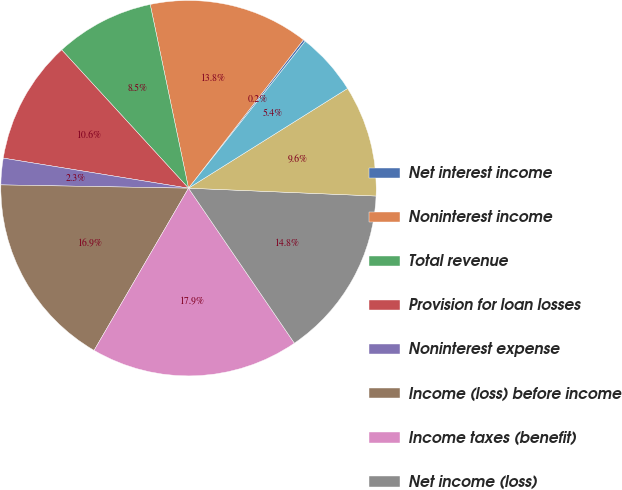<chart> <loc_0><loc_0><loc_500><loc_500><pie_chart><fcel>Net interest income<fcel>Noninterest income<fcel>Total revenue<fcel>Provision for loan losses<fcel>Noninterest expense<fcel>Income (loss) before income<fcel>Income taxes (benefit)<fcel>Net income (loss)<fcel>Net earnings (loss) applicable<fcel>Net earnings (loss) - diluted<nl><fcel>0.19%<fcel>13.76%<fcel>8.54%<fcel>10.63%<fcel>2.28%<fcel>16.89%<fcel>17.93%<fcel>14.8%<fcel>9.58%<fcel>5.41%<nl></chart> 